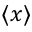Convert formula to latex. <formula><loc_0><loc_0><loc_500><loc_500>\langle x \rangle</formula> 